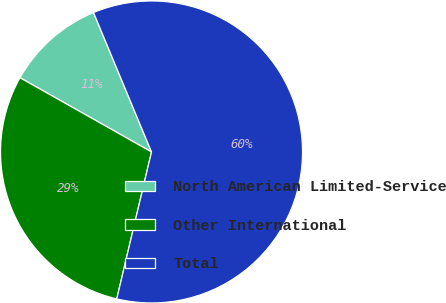Convert chart to OTSL. <chart><loc_0><loc_0><loc_500><loc_500><pie_chart><fcel>North American Limited-Service<fcel>Other International<fcel>Total<nl><fcel>10.55%<fcel>29.48%<fcel>59.97%<nl></chart> 